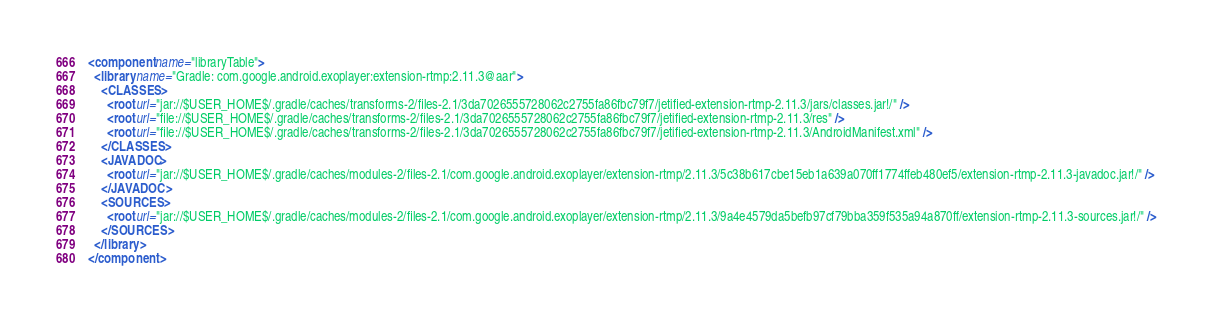<code> <loc_0><loc_0><loc_500><loc_500><_XML_><component name="libraryTable">
  <library name="Gradle: com.google.android.exoplayer:extension-rtmp:2.11.3@aar">
    <CLASSES>
      <root url="jar://$USER_HOME$/.gradle/caches/transforms-2/files-2.1/3da7026555728062c2755fa86fbc79f7/jetified-extension-rtmp-2.11.3/jars/classes.jar!/" />
      <root url="file://$USER_HOME$/.gradle/caches/transforms-2/files-2.1/3da7026555728062c2755fa86fbc79f7/jetified-extension-rtmp-2.11.3/res" />
      <root url="file://$USER_HOME$/.gradle/caches/transforms-2/files-2.1/3da7026555728062c2755fa86fbc79f7/jetified-extension-rtmp-2.11.3/AndroidManifest.xml" />
    </CLASSES>
    <JAVADOC>
      <root url="jar://$USER_HOME$/.gradle/caches/modules-2/files-2.1/com.google.android.exoplayer/extension-rtmp/2.11.3/5c38b617cbe15eb1a639a070ff1774ffeb480ef5/extension-rtmp-2.11.3-javadoc.jar!/" />
    </JAVADOC>
    <SOURCES>
      <root url="jar://$USER_HOME$/.gradle/caches/modules-2/files-2.1/com.google.android.exoplayer/extension-rtmp/2.11.3/9a4e4579da5befb97cf79bba359f535a94a870ff/extension-rtmp-2.11.3-sources.jar!/" />
    </SOURCES>
  </library>
</component></code> 